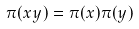<formula> <loc_0><loc_0><loc_500><loc_500>\pi ( x y ) = \pi ( x ) \pi ( y )</formula> 